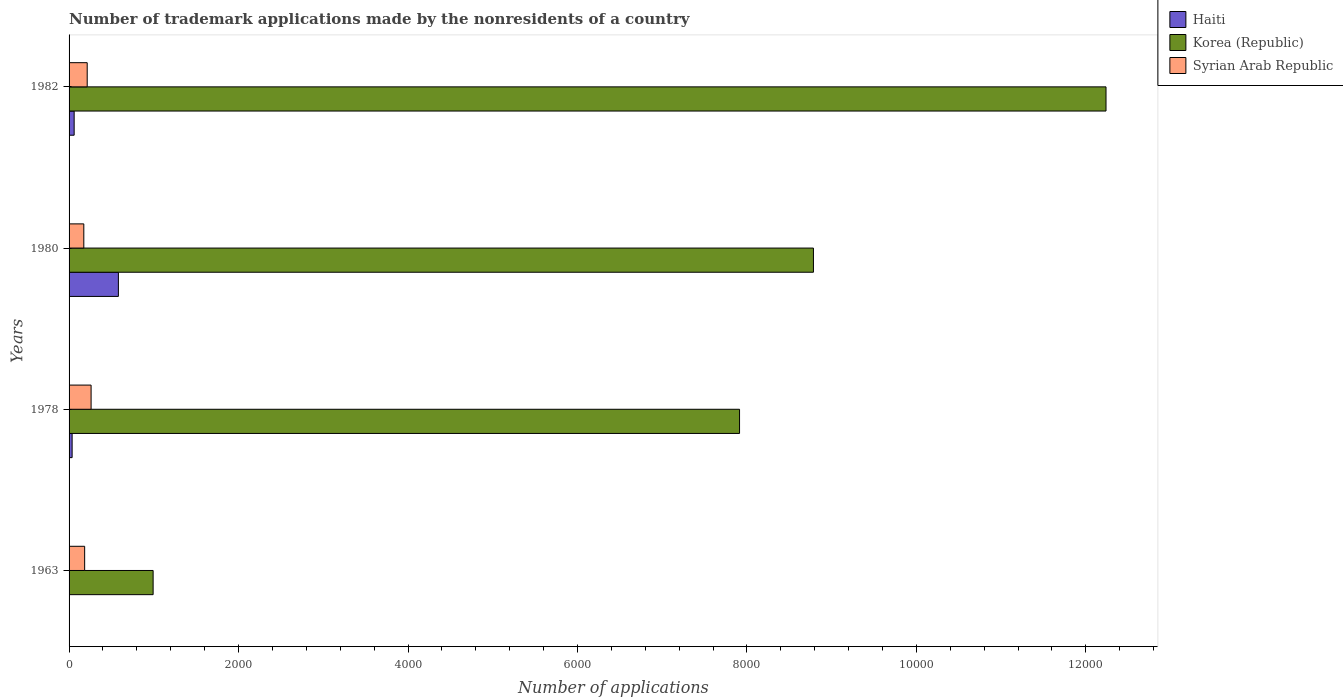How many different coloured bars are there?
Your answer should be very brief. 3. Are the number of bars per tick equal to the number of legend labels?
Your answer should be very brief. Yes. Are the number of bars on each tick of the Y-axis equal?
Provide a short and direct response. Yes. How many bars are there on the 3rd tick from the top?
Make the answer very short. 3. What is the label of the 3rd group of bars from the top?
Make the answer very short. 1978. In how many cases, is the number of bars for a given year not equal to the number of legend labels?
Make the answer very short. 0. What is the number of trademark applications made by the nonresidents in Haiti in 1980?
Make the answer very short. 582. Across all years, what is the maximum number of trademark applications made by the nonresidents in Korea (Republic)?
Provide a short and direct response. 1.22e+04. Across all years, what is the minimum number of trademark applications made by the nonresidents in Syrian Arab Republic?
Keep it short and to the point. 174. In which year was the number of trademark applications made by the nonresidents in Syrian Arab Republic maximum?
Provide a succinct answer. 1978. In which year was the number of trademark applications made by the nonresidents in Syrian Arab Republic minimum?
Provide a succinct answer. 1980. What is the total number of trademark applications made by the nonresidents in Korea (Republic) in the graph?
Your answer should be compact. 2.99e+04. What is the difference between the number of trademark applications made by the nonresidents in Korea (Republic) in 1963 and that in 1978?
Offer a very short reply. -6921. What is the difference between the number of trademark applications made by the nonresidents in Syrian Arab Republic in 1978 and the number of trademark applications made by the nonresidents in Haiti in 1963?
Your answer should be compact. 257. What is the average number of trademark applications made by the nonresidents in Korea (Republic) per year?
Give a very brief answer. 7482. In the year 1963, what is the difference between the number of trademark applications made by the nonresidents in Syrian Arab Republic and number of trademark applications made by the nonresidents in Korea (Republic)?
Keep it short and to the point. -808. In how many years, is the number of trademark applications made by the nonresidents in Syrian Arab Republic greater than 12400 ?
Ensure brevity in your answer.  0. What is the ratio of the number of trademark applications made by the nonresidents in Haiti in 1963 to that in 1978?
Offer a terse response. 0.08. Is the number of trademark applications made by the nonresidents in Syrian Arab Republic in 1980 less than that in 1982?
Offer a very short reply. Yes. Is the difference between the number of trademark applications made by the nonresidents in Syrian Arab Republic in 1963 and 1980 greater than the difference between the number of trademark applications made by the nonresidents in Korea (Republic) in 1963 and 1980?
Your response must be concise. Yes. What is the difference between the highest and the lowest number of trademark applications made by the nonresidents in Syrian Arab Republic?
Your answer should be very brief. 86. In how many years, is the number of trademark applications made by the nonresidents in Korea (Republic) greater than the average number of trademark applications made by the nonresidents in Korea (Republic) taken over all years?
Make the answer very short. 3. Is the sum of the number of trademark applications made by the nonresidents in Korea (Republic) in 1980 and 1982 greater than the maximum number of trademark applications made by the nonresidents in Haiti across all years?
Offer a terse response. Yes. What does the 3rd bar from the top in 1982 represents?
Offer a terse response. Haiti. What does the 1st bar from the bottom in 1978 represents?
Keep it short and to the point. Haiti. What is the difference between two consecutive major ticks on the X-axis?
Offer a terse response. 2000. Are the values on the major ticks of X-axis written in scientific E-notation?
Make the answer very short. No. Does the graph contain any zero values?
Your answer should be compact. No. How many legend labels are there?
Keep it short and to the point. 3. What is the title of the graph?
Make the answer very short. Number of trademark applications made by the nonresidents of a country. What is the label or title of the X-axis?
Keep it short and to the point. Number of applications. What is the label or title of the Y-axis?
Make the answer very short. Years. What is the Number of applications of Korea (Republic) in 1963?
Your response must be concise. 992. What is the Number of applications of Syrian Arab Republic in 1963?
Your answer should be very brief. 184. What is the Number of applications in Haiti in 1978?
Keep it short and to the point. 36. What is the Number of applications of Korea (Republic) in 1978?
Offer a very short reply. 7913. What is the Number of applications in Syrian Arab Republic in 1978?
Make the answer very short. 260. What is the Number of applications of Haiti in 1980?
Offer a terse response. 582. What is the Number of applications in Korea (Republic) in 1980?
Your response must be concise. 8785. What is the Number of applications in Syrian Arab Republic in 1980?
Give a very brief answer. 174. What is the Number of applications of Korea (Republic) in 1982?
Offer a terse response. 1.22e+04. What is the Number of applications in Syrian Arab Republic in 1982?
Your answer should be very brief. 214. Across all years, what is the maximum Number of applications in Haiti?
Provide a short and direct response. 582. Across all years, what is the maximum Number of applications of Korea (Republic)?
Your answer should be compact. 1.22e+04. Across all years, what is the maximum Number of applications in Syrian Arab Republic?
Your response must be concise. 260. Across all years, what is the minimum Number of applications in Korea (Republic)?
Your response must be concise. 992. Across all years, what is the minimum Number of applications in Syrian Arab Republic?
Your answer should be very brief. 174. What is the total Number of applications in Haiti in the graph?
Provide a succinct answer. 681. What is the total Number of applications in Korea (Republic) in the graph?
Provide a short and direct response. 2.99e+04. What is the total Number of applications of Syrian Arab Republic in the graph?
Your answer should be compact. 832. What is the difference between the Number of applications in Haiti in 1963 and that in 1978?
Your answer should be compact. -33. What is the difference between the Number of applications in Korea (Republic) in 1963 and that in 1978?
Ensure brevity in your answer.  -6921. What is the difference between the Number of applications in Syrian Arab Republic in 1963 and that in 1978?
Your response must be concise. -76. What is the difference between the Number of applications in Haiti in 1963 and that in 1980?
Keep it short and to the point. -579. What is the difference between the Number of applications of Korea (Republic) in 1963 and that in 1980?
Offer a terse response. -7793. What is the difference between the Number of applications in Syrian Arab Republic in 1963 and that in 1980?
Make the answer very short. 10. What is the difference between the Number of applications of Haiti in 1963 and that in 1982?
Offer a terse response. -57. What is the difference between the Number of applications of Korea (Republic) in 1963 and that in 1982?
Give a very brief answer. -1.12e+04. What is the difference between the Number of applications in Haiti in 1978 and that in 1980?
Offer a terse response. -546. What is the difference between the Number of applications in Korea (Republic) in 1978 and that in 1980?
Offer a terse response. -872. What is the difference between the Number of applications of Syrian Arab Republic in 1978 and that in 1980?
Provide a succinct answer. 86. What is the difference between the Number of applications of Korea (Republic) in 1978 and that in 1982?
Give a very brief answer. -4325. What is the difference between the Number of applications in Haiti in 1980 and that in 1982?
Provide a short and direct response. 522. What is the difference between the Number of applications of Korea (Republic) in 1980 and that in 1982?
Your response must be concise. -3453. What is the difference between the Number of applications of Haiti in 1963 and the Number of applications of Korea (Republic) in 1978?
Offer a terse response. -7910. What is the difference between the Number of applications in Haiti in 1963 and the Number of applications in Syrian Arab Republic in 1978?
Your answer should be compact. -257. What is the difference between the Number of applications in Korea (Republic) in 1963 and the Number of applications in Syrian Arab Republic in 1978?
Provide a short and direct response. 732. What is the difference between the Number of applications in Haiti in 1963 and the Number of applications in Korea (Republic) in 1980?
Your answer should be very brief. -8782. What is the difference between the Number of applications of Haiti in 1963 and the Number of applications of Syrian Arab Republic in 1980?
Ensure brevity in your answer.  -171. What is the difference between the Number of applications of Korea (Republic) in 1963 and the Number of applications of Syrian Arab Republic in 1980?
Keep it short and to the point. 818. What is the difference between the Number of applications in Haiti in 1963 and the Number of applications in Korea (Republic) in 1982?
Make the answer very short. -1.22e+04. What is the difference between the Number of applications of Haiti in 1963 and the Number of applications of Syrian Arab Republic in 1982?
Give a very brief answer. -211. What is the difference between the Number of applications of Korea (Republic) in 1963 and the Number of applications of Syrian Arab Republic in 1982?
Your answer should be compact. 778. What is the difference between the Number of applications of Haiti in 1978 and the Number of applications of Korea (Republic) in 1980?
Your answer should be compact. -8749. What is the difference between the Number of applications in Haiti in 1978 and the Number of applications in Syrian Arab Republic in 1980?
Keep it short and to the point. -138. What is the difference between the Number of applications in Korea (Republic) in 1978 and the Number of applications in Syrian Arab Republic in 1980?
Your response must be concise. 7739. What is the difference between the Number of applications of Haiti in 1978 and the Number of applications of Korea (Republic) in 1982?
Your answer should be very brief. -1.22e+04. What is the difference between the Number of applications in Haiti in 1978 and the Number of applications in Syrian Arab Republic in 1982?
Offer a very short reply. -178. What is the difference between the Number of applications of Korea (Republic) in 1978 and the Number of applications of Syrian Arab Republic in 1982?
Provide a succinct answer. 7699. What is the difference between the Number of applications of Haiti in 1980 and the Number of applications of Korea (Republic) in 1982?
Keep it short and to the point. -1.17e+04. What is the difference between the Number of applications of Haiti in 1980 and the Number of applications of Syrian Arab Republic in 1982?
Keep it short and to the point. 368. What is the difference between the Number of applications of Korea (Republic) in 1980 and the Number of applications of Syrian Arab Republic in 1982?
Your answer should be very brief. 8571. What is the average Number of applications of Haiti per year?
Provide a short and direct response. 170.25. What is the average Number of applications in Korea (Republic) per year?
Keep it short and to the point. 7482. What is the average Number of applications of Syrian Arab Republic per year?
Offer a very short reply. 208. In the year 1963, what is the difference between the Number of applications in Haiti and Number of applications in Korea (Republic)?
Offer a very short reply. -989. In the year 1963, what is the difference between the Number of applications of Haiti and Number of applications of Syrian Arab Republic?
Provide a short and direct response. -181. In the year 1963, what is the difference between the Number of applications in Korea (Republic) and Number of applications in Syrian Arab Republic?
Your answer should be compact. 808. In the year 1978, what is the difference between the Number of applications of Haiti and Number of applications of Korea (Republic)?
Your response must be concise. -7877. In the year 1978, what is the difference between the Number of applications of Haiti and Number of applications of Syrian Arab Republic?
Keep it short and to the point. -224. In the year 1978, what is the difference between the Number of applications of Korea (Republic) and Number of applications of Syrian Arab Republic?
Offer a very short reply. 7653. In the year 1980, what is the difference between the Number of applications in Haiti and Number of applications in Korea (Republic)?
Your response must be concise. -8203. In the year 1980, what is the difference between the Number of applications of Haiti and Number of applications of Syrian Arab Republic?
Offer a terse response. 408. In the year 1980, what is the difference between the Number of applications in Korea (Republic) and Number of applications in Syrian Arab Republic?
Your response must be concise. 8611. In the year 1982, what is the difference between the Number of applications of Haiti and Number of applications of Korea (Republic)?
Your answer should be compact. -1.22e+04. In the year 1982, what is the difference between the Number of applications of Haiti and Number of applications of Syrian Arab Republic?
Provide a succinct answer. -154. In the year 1982, what is the difference between the Number of applications in Korea (Republic) and Number of applications in Syrian Arab Republic?
Your answer should be compact. 1.20e+04. What is the ratio of the Number of applications in Haiti in 1963 to that in 1978?
Your answer should be compact. 0.08. What is the ratio of the Number of applications of Korea (Republic) in 1963 to that in 1978?
Your response must be concise. 0.13. What is the ratio of the Number of applications in Syrian Arab Republic in 1963 to that in 1978?
Your answer should be compact. 0.71. What is the ratio of the Number of applications in Haiti in 1963 to that in 1980?
Your answer should be compact. 0.01. What is the ratio of the Number of applications of Korea (Republic) in 1963 to that in 1980?
Your response must be concise. 0.11. What is the ratio of the Number of applications in Syrian Arab Republic in 1963 to that in 1980?
Your response must be concise. 1.06. What is the ratio of the Number of applications of Korea (Republic) in 1963 to that in 1982?
Offer a terse response. 0.08. What is the ratio of the Number of applications in Syrian Arab Republic in 1963 to that in 1982?
Your answer should be compact. 0.86. What is the ratio of the Number of applications in Haiti in 1978 to that in 1980?
Give a very brief answer. 0.06. What is the ratio of the Number of applications of Korea (Republic) in 1978 to that in 1980?
Make the answer very short. 0.9. What is the ratio of the Number of applications in Syrian Arab Republic in 1978 to that in 1980?
Make the answer very short. 1.49. What is the ratio of the Number of applications of Korea (Republic) in 1978 to that in 1982?
Your answer should be very brief. 0.65. What is the ratio of the Number of applications in Syrian Arab Republic in 1978 to that in 1982?
Provide a short and direct response. 1.22. What is the ratio of the Number of applications of Korea (Republic) in 1980 to that in 1982?
Offer a very short reply. 0.72. What is the ratio of the Number of applications of Syrian Arab Republic in 1980 to that in 1982?
Offer a terse response. 0.81. What is the difference between the highest and the second highest Number of applications in Haiti?
Make the answer very short. 522. What is the difference between the highest and the second highest Number of applications of Korea (Republic)?
Your answer should be very brief. 3453. What is the difference between the highest and the lowest Number of applications of Haiti?
Give a very brief answer. 579. What is the difference between the highest and the lowest Number of applications in Korea (Republic)?
Keep it short and to the point. 1.12e+04. What is the difference between the highest and the lowest Number of applications of Syrian Arab Republic?
Keep it short and to the point. 86. 